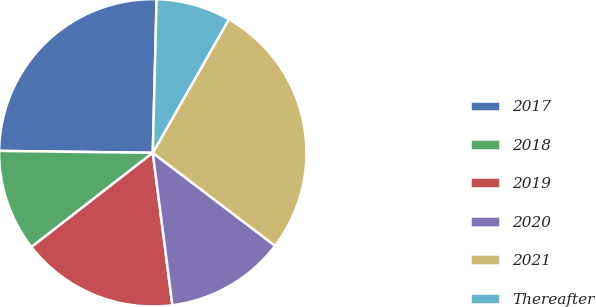<chart> <loc_0><loc_0><loc_500><loc_500><pie_chart><fcel>2017<fcel>2018<fcel>2019<fcel>2020<fcel>2021<fcel>Thereafter<nl><fcel>25.2%<fcel>10.71%<fcel>16.53%<fcel>12.62%<fcel>27.1%<fcel>7.85%<nl></chart> 